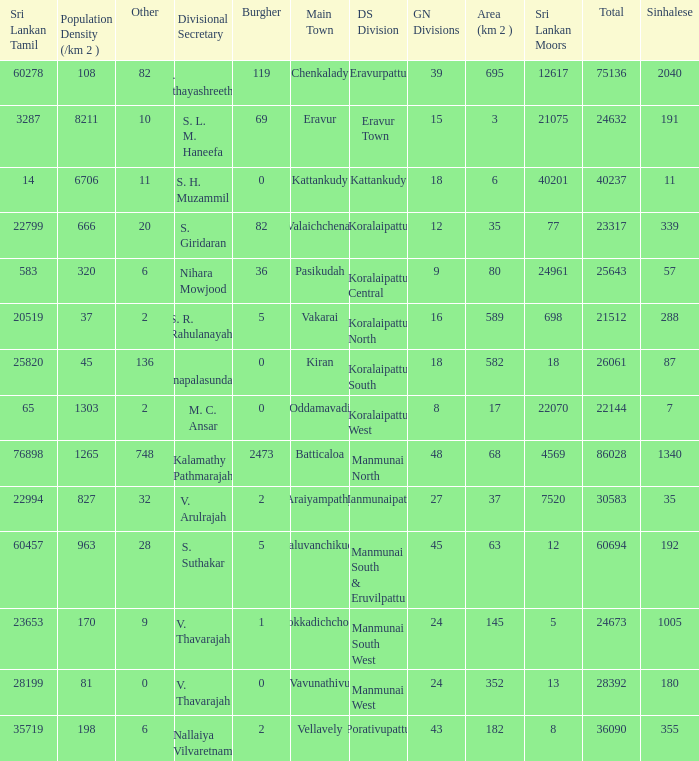What DS division has S. L. M. Haneefa as the divisional secretary? Eravur Town. 